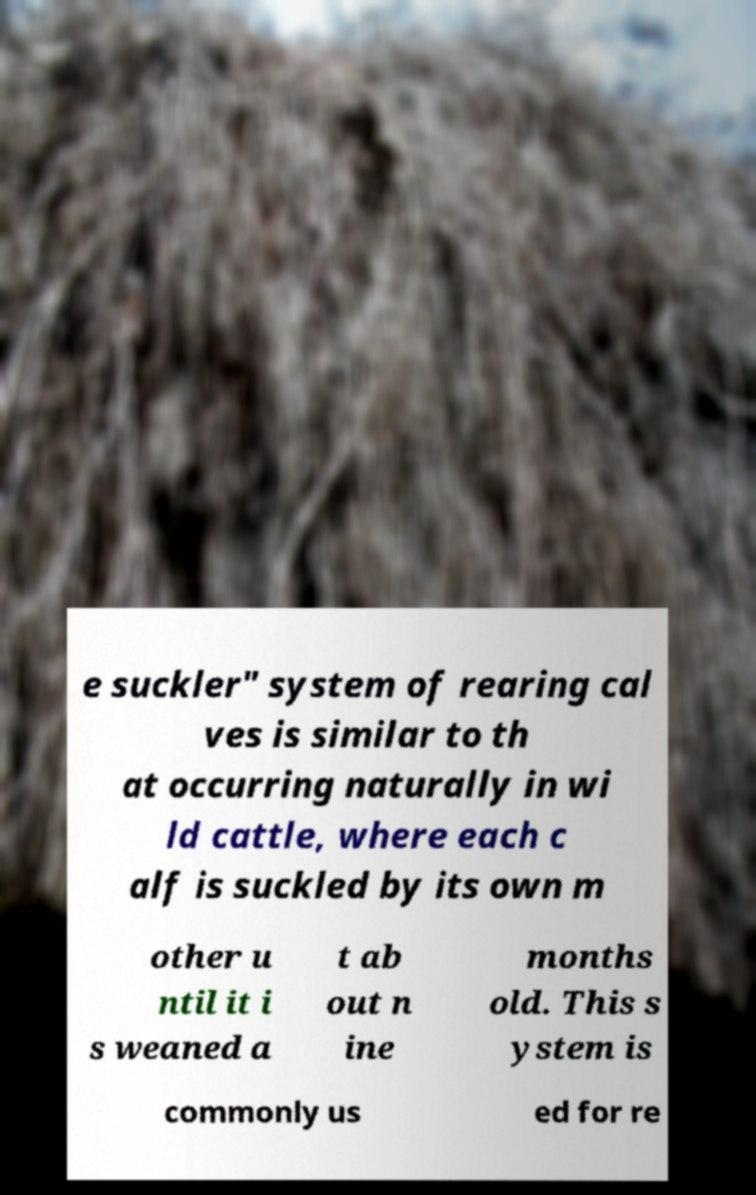Can you accurately transcribe the text from the provided image for me? e suckler" system of rearing cal ves is similar to th at occurring naturally in wi ld cattle, where each c alf is suckled by its own m other u ntil it i s weaned a t ab out n ine months old. This s ystem is commonly us ed for re 